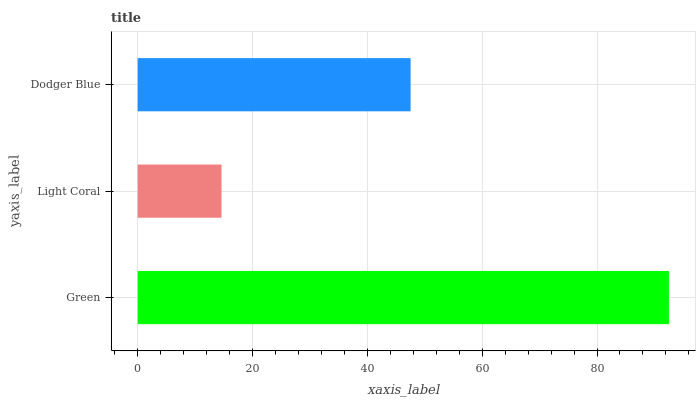Is Light Coral the minimum?
Answer yes or no. Yes. Is Green the maximum?
Answer yes or no. Yes. Is Dodger Blue the minimum?
Answer yes or no. No. Is Dodger Blue the maximum?
Answer yes or no. No. Is Dodger Blue greater than Light Coral?
Answer yes or no. Yes. Is Light Coral less than Dodger Blue?
Answer yes or no. Yes. Is Light Coral greater than Dodger Blue?
Answer yes or no. No. Is Dodger Blue less than Light Coral?
Answer yes or no. No. Is Dodger Blue the high median?
Answer yes or no. Yes. Is Dodger Blue the low median?
Answer yes or no. Yes. Is Light Coral the high median?
Answer yes or no. No. Is Light Coral the low median?
Answer yes or no. No. 